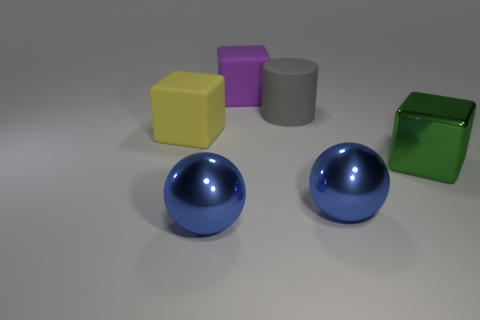Subtract all yellow matte cubes. How many cubes are left? 2 Subtract all yellow cubes. How many cubes are left? 2 Add 3 brown metallic balls. How many objects exist? 9 Subtract 1 cylinders. How many cylinders are left? 0 Add 2 purple matte cubes. How many purple matte cubes exist? 3 Subtract 0 brown cylinders. How many objects are left? 6 Subtract all spheres. How many objects are left? 4 Subtract all brown cylinders. Subtract all cyan blocks. How many cylinders are left? 1 Subtract all brown spheres. How many red cubes are left? 0 Subtract all big matte cylinders. Subtract all large green cubes. How many objects are left? 4 